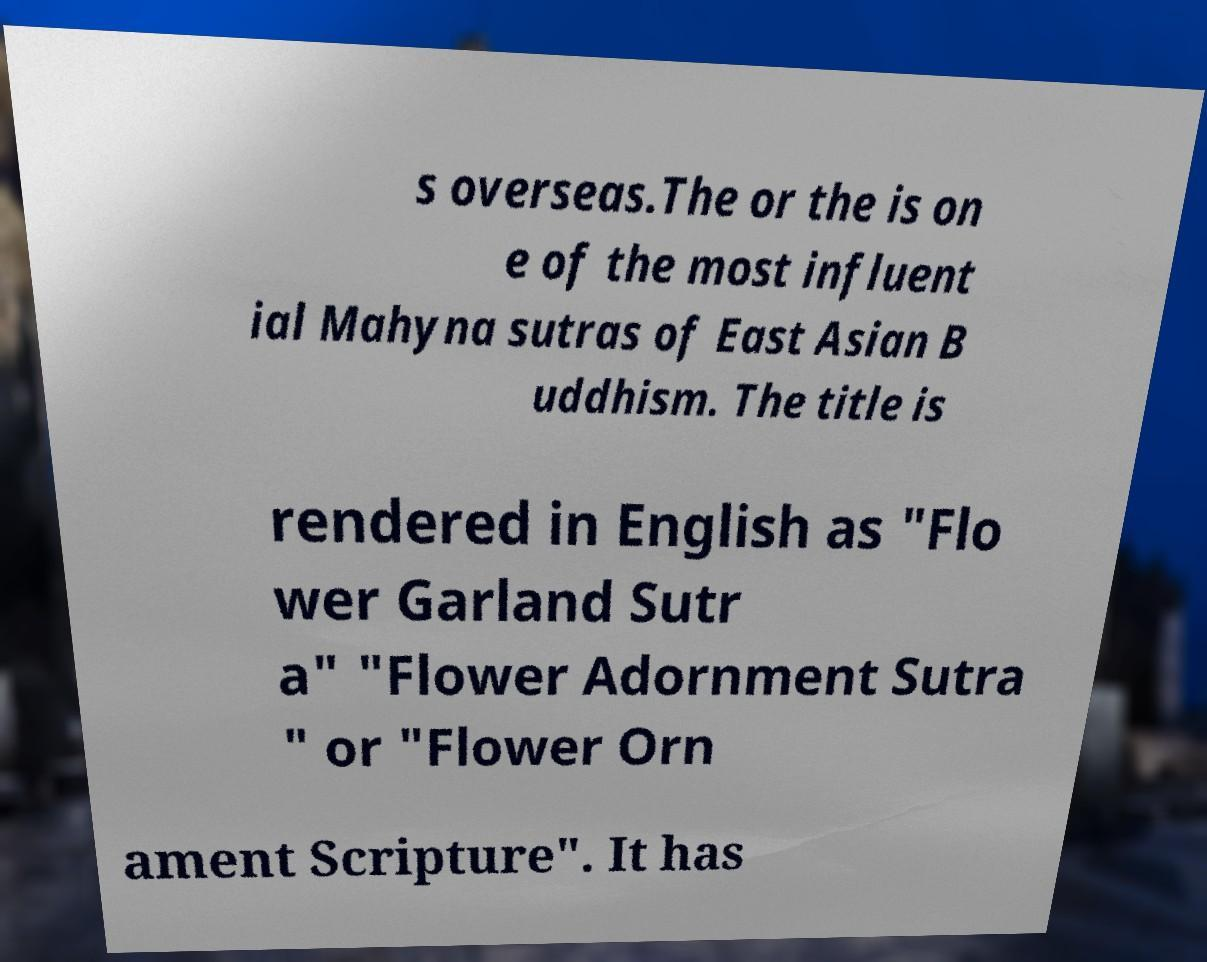Can you read and provide the text displayed in the image?This photo seems to have some interesting text. Can you extract and type it out for me? s overseas.The or the is on e of the most influent ial Mahyna sutras of East Asian B uddhism. The title is rendered in English as "Flo wer Garland Sutr a" "Flower Adornment Sutra " or "Flower Orn ament Scripture". It has 